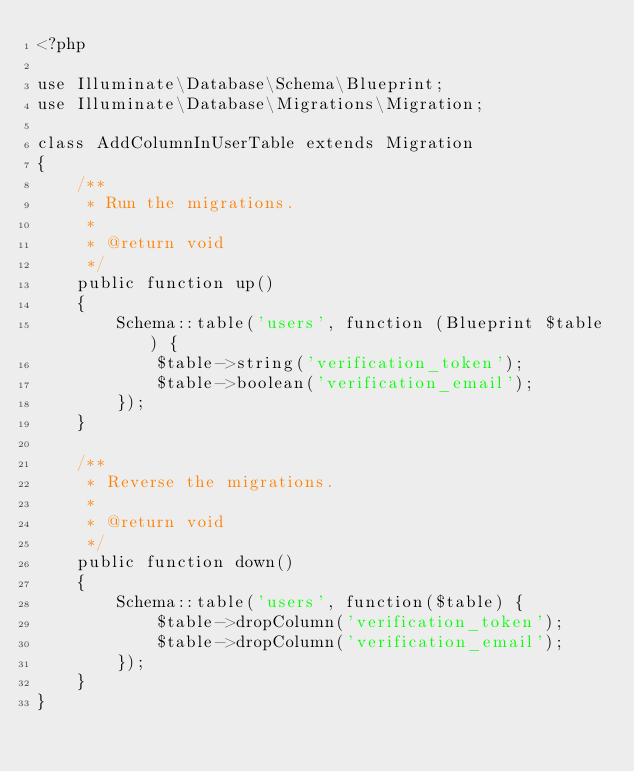<code> <loc_0><loc_0><loc_500><loc_500><_PHP_><?php

use Illuminate\Database\Schema\Blueprint;
use Illuminate\Database\Migrations\Migration;

class AddColumnInUserTable extends Migration
{
    /**
     * Run the migrations.
     *
     * @return void
     */
    public function up()
    {
        Schema::table('users', function (Blueprint $table) {
            $table->string('verification_token');
            $table->boolean('verification_email');
        });
    }

    /**
     * Reverse the migrations.
     *
     * @return void
     */
    public function down()
    {
        Schema::table('users', function($table) {
            $table->dropColumn('verification_token');
            $table->dropColumn('verification_email');
        });
    }
}
</code> 